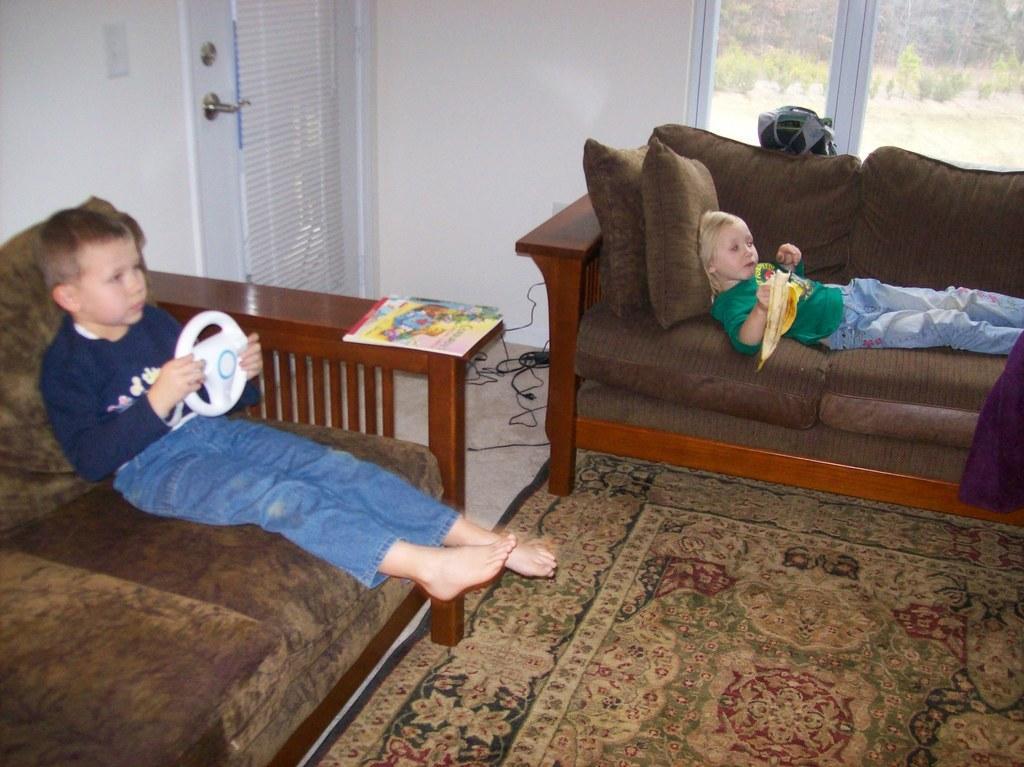How would you summarize this image in a sentence or two? Here we can see two children sitting on sofa, the left one is sitting on sofa and the right one is lying on the sofa and we can see a carpet on the floor and at the the end of it we can see a door and at the right top we can see a window 